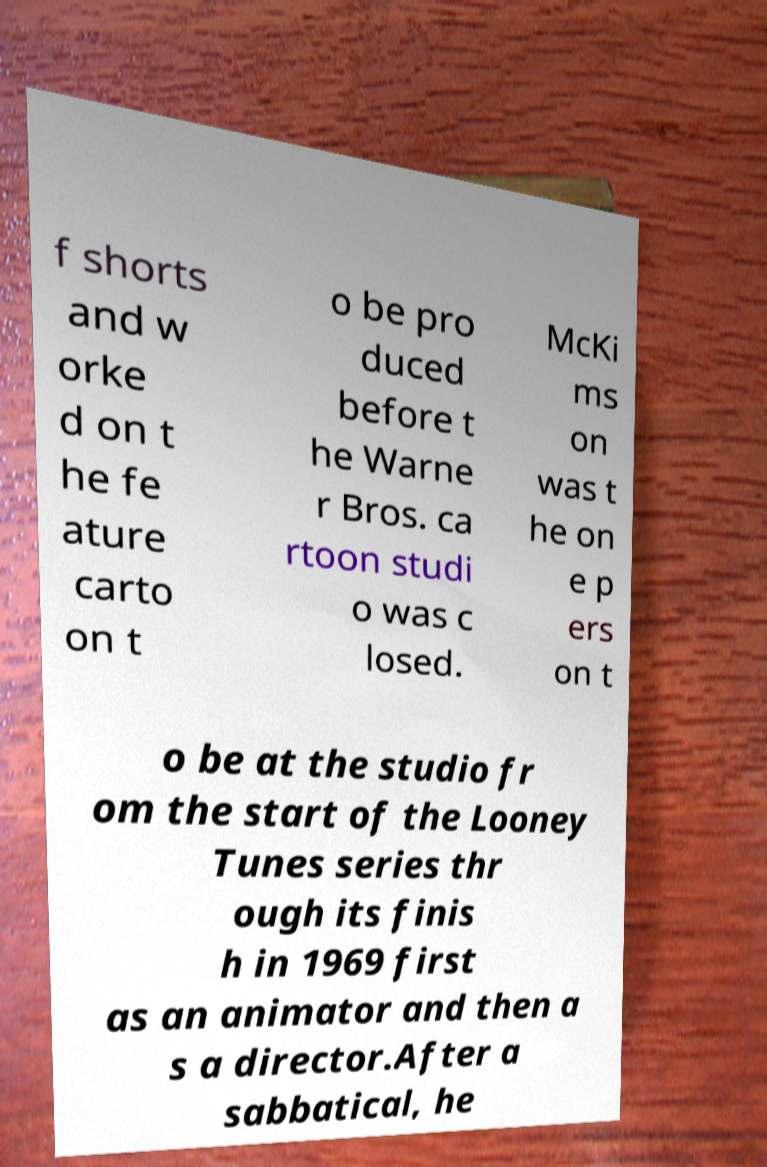For documentation purposes, I need the text within this image transcribed. Could you provide that? f shorts and w orke d on t he fe ature carto on t o be pro duced before t he Warne r Bros. ca rtoon studi o was c losed. McKi ms on was t he on e p ers on t o be at the studio fr om the start of the Looney Tunes series thr ough its finis h in 1969 first as an animator and then a s a director.After a sabbatical, he 